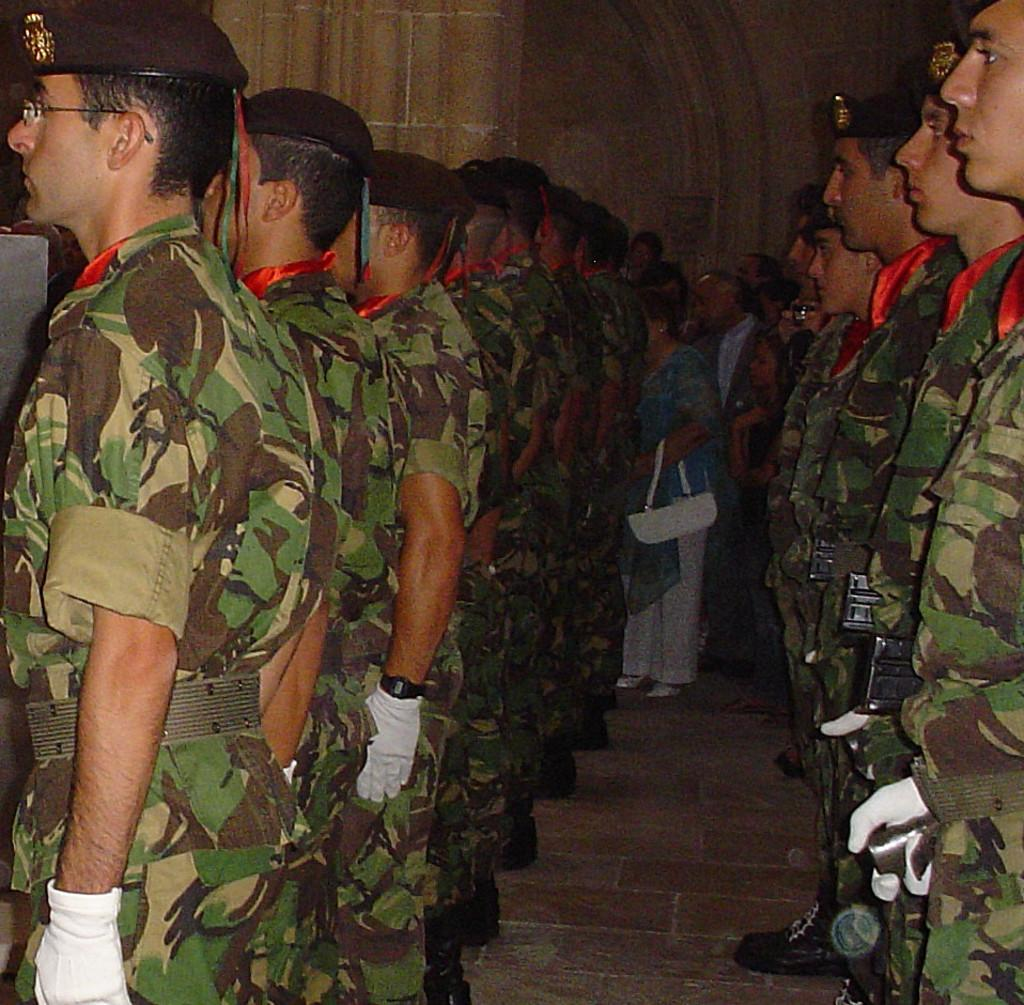What can be seen in the image regarding the people present? There is a group of people in the image, and some of them are wearing caps. Can you describe the woman in the background of the image? The woman in the background is holding a bag. What else is visible in the image besides the people and the woman? There are weapons visible in the image. Can you describe the seashore in the image? There is no seashore present in the image. What type of mine is visible in the image? There is no mine present in the image. 